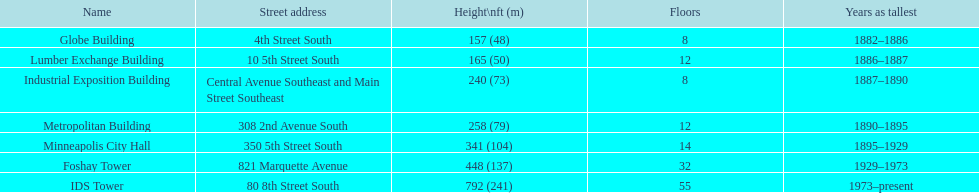Help me parse the entirety of this table. {'header': ['Name', 'Street address', 'Height\\nft (m)', 'Floors', 'Years as tallest'], 'rows': [['Globe Building', '4th Street South', '157 (48)', '8', '1882–1886'], ['Lumber Exchange Building', '10 5th Street South', '165 (50)', '12', '1886–1887'], ['Industrial Exposition Building', 'Central Avenue Southeast and Main Street Southeast', '240 (73)', '8', '1887–1890'], ['Metropolitan Building', '308 2nd Avenue South', '258 (79)', '12', '1890–1895'], ['Minneapolis City Hall', '350 5th Street South', '341 (104)', '14', '1895–1929'], ['Foshay Tower', '821 Marquette Avenue', '448 (137)', '32', '1929–1973'], ['IDS Tower', '80 8th Street South', '792 (241)', '55', '1973–present']]} How long did the lumber exchange building stand as the tallest building? 1 year. 